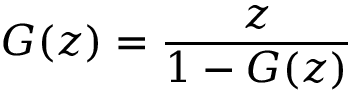Convert formula to latex. <formula><loc_0><loc_0><loc_500><loc_500>G ( z ) = { \frac { z } { 1 - G ( z ) } }</formula> 